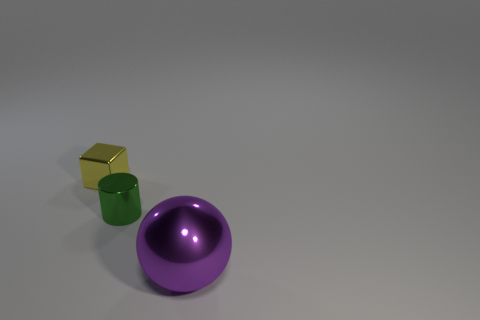The large shiny thing has what shape?
Offer a very short reply. Sphere. There is a cylinder that is the same size as the block; what is its material?
Your answer should be compact. Metal. Is there anything else that is the same size as the green cylinder?
Make the answer very short. Yes. What number of things are small brown matte blocks or metallic objects behind the large purple metal ball?
Keep it short and to the point. 2. There is a cylinder that is made of the same material as the cube; what is its size?
Keep it short and to the point. Small. What shape is the metal object that is to the left of the tiny object in front of the small shiny block?
Make the answer very short. Cube. There is a metal object that is both left of the large shiny sphere and in front of the tiny shiny cube; what is its size?
Give a very brief answer. Small. Are there any big purple things that have the same shape as the tiny yellow thing?
Make the answer very short. No. Is there any other thing that has the same shape as the tiny yellow metal object?
Ensure brevity in your answer.  No. What is the material of the object left of the tiny object that is in front of the small object behind the tiny green thing?
Give a very brief answer. Metal. 